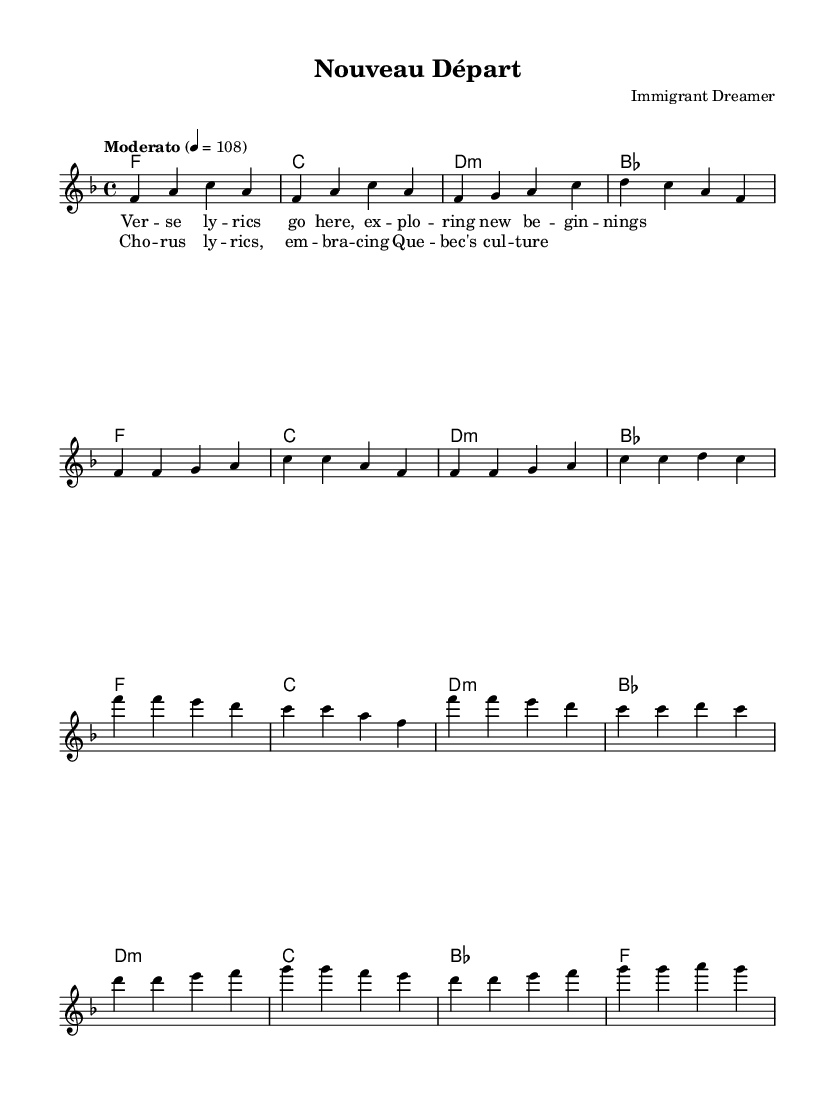What is the key signature of this music? The key signature is determined by the presence of sharps or flats at the beginning of the staff. This piece is in F major, which has one flat, B flat.
Answer: F major What is the time signature of this score? The time signature is indicated at the beginning of the staff; it shows that there are four beats per measure and the quarter note gets one beat. Therefore, it is 4/4.
Answer: 4/4 What is the tempo marking of this piece? The tempo marking is found at the beginning and specifies the speed of the piece, indicated as "Moderato" which is a moderate pace, and the number 108 indicates a specific BPM (beats per minute).
Answer: Moderato How many measures are in the chorus? By examining the chorus section, there are two lines of lyrics provided with two measures for each line, totaling four measures in the chorus.
Answer: 4 What is the overall theme of the lyrics? By interpreting the lyrics mentioned which include phrases about new beginnings and embracing Quebec's culture, the theme is focused on immigrant experiences and cultural integration.
Answer: Immigrant experiences Which part of the song is labeled as the bridge? The bridge section is typically a contrasting part that prepares for a return to the chorus; it is indicated in the music as the section that follows the chorus in structure. Here, it’s clearly marked as the “Bridge.”
Answer: Bridge 